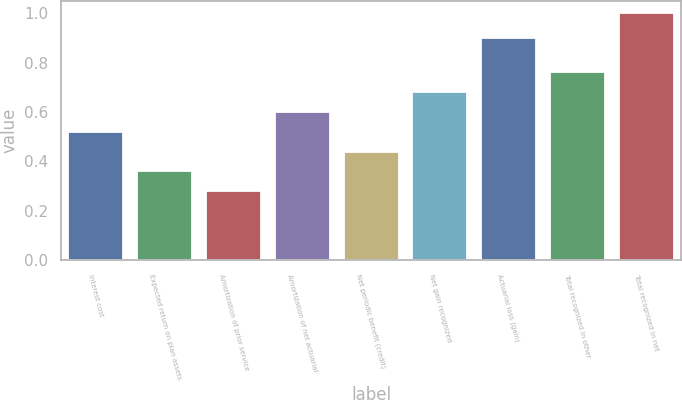Convert chart. <chart><loc_0><loc_0><loc_500><loc_500><bar_chart><fcel>Interest cost<fcel>Expected return on plan assets<fcel>Amortization of prior service<fcel>Amortization of net actuarial<fcel>Net periodic benefit (credit)<fcel>Net gain recognized<fcel>Actuarial loss (gain)<fcel>Total recognized in other<fcel>Total recognized in net<nl><fcel>0.52<fcel>0.36<fcel>0.28<fcel>0.6<fcel>0.44<fcel>0.68<fcel>0.9<fcel>0.76<fcel>1<nl></chart> 